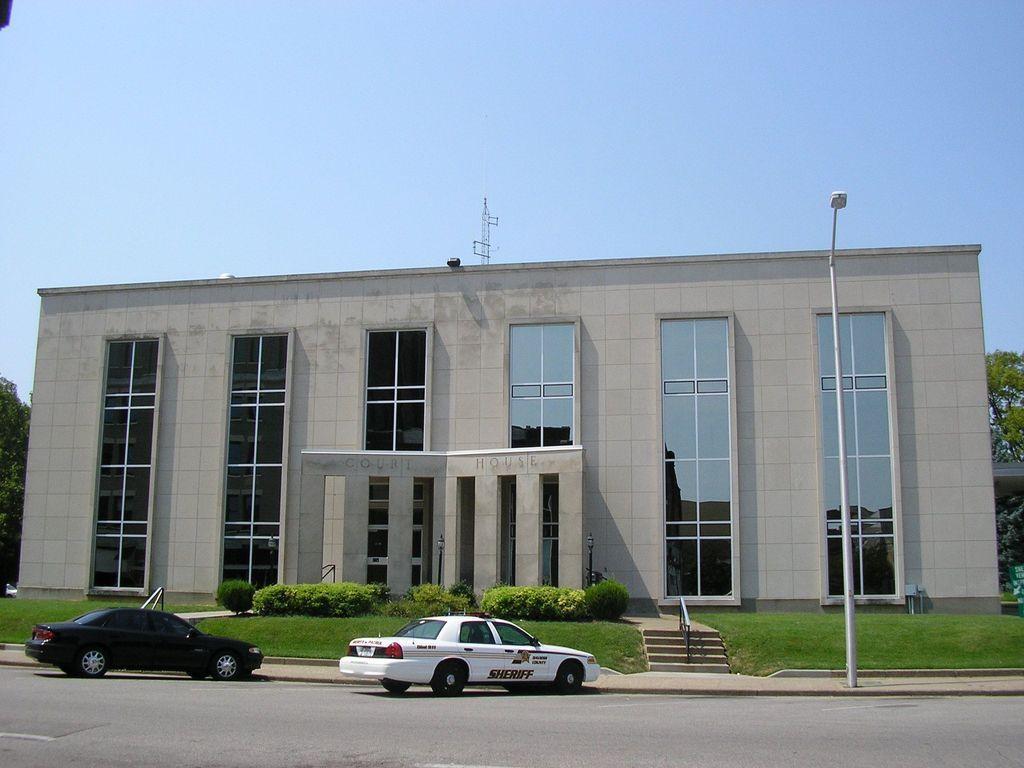Could you give a brief overview of what you see in this image? In this picture we can see two cars in the front, in the background there is a building, we can see glasses of the building, there are some shrubs, grass and stairs in the middle, on the right side there is a pole and a light, we can see trees on the right side and left side, we can see the sky at the top of the picture. 